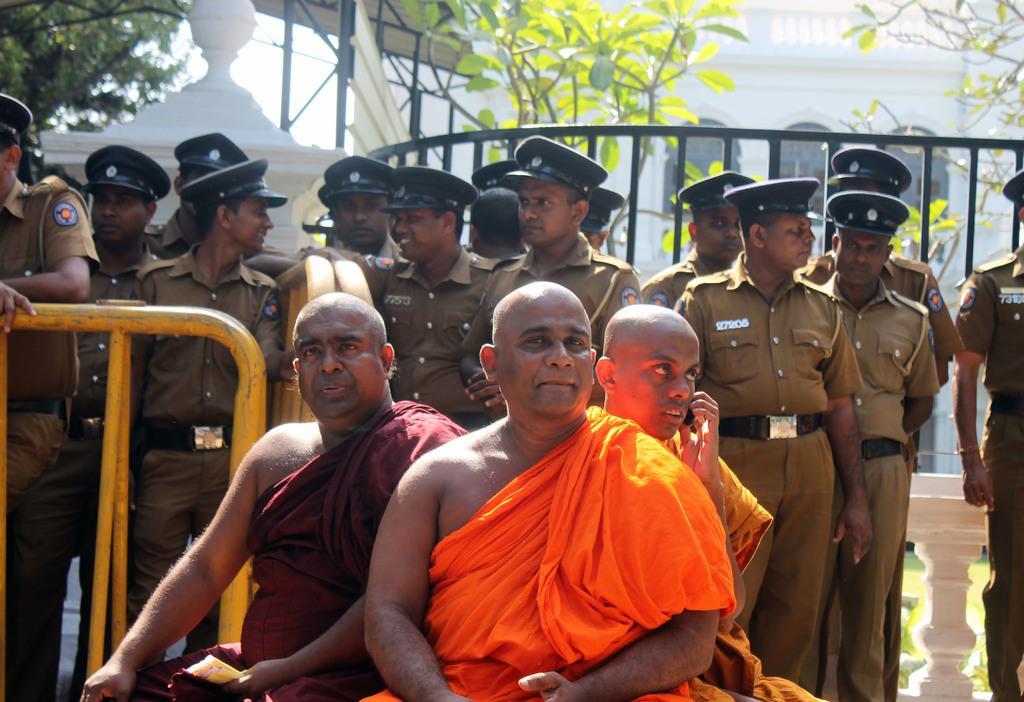Could you give a brief overview of what you see in this image? In the center of the image we can see three persons are sitting and they are in different costumes. Among them, we can see two persons are holding some objects and one person is smiling. In the background, we can see one building, fences, trees, few people are standing and a few other objects. And they are in different costumes and we can see they are wearing caps. 